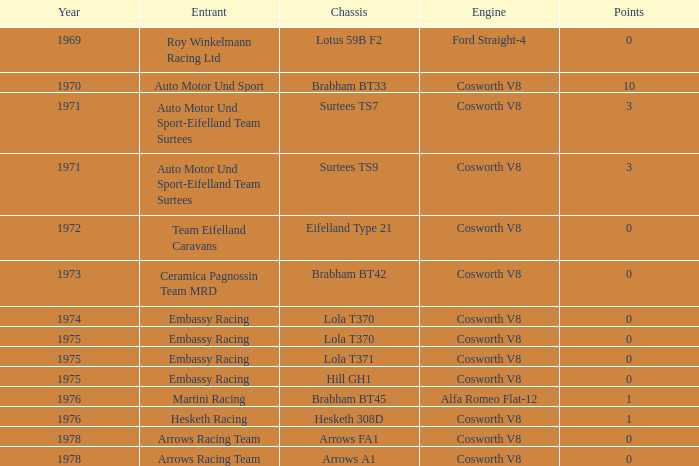What was the overall sum of points in 1978 with an arrow fa1 chassis? 0.0. 